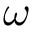Convert formula to latex. <formula><loc_0><loc_0><loc_500><loc_500>\omega</formula> 